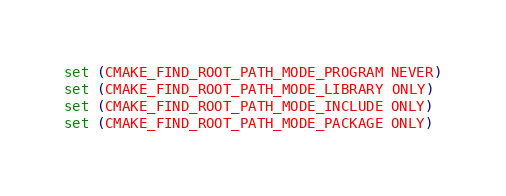<code> <loc_0><loc_0><loc_500><loc_500><_CMake_>
set (CMAKE_FIND_ROOT_PATH_MODE_PROGRAM NEVER)
set (CMAKE_FIND_ROOT_PATH_MODE_LIBRARY ONLY)
set (CMAKE_FIND_ROOT_PATH_MODE_INCLUDE ONLY)
set (CMAKE_FIND_ROOT_PATH_MODE_PACKAGE ONLY)
</code> 